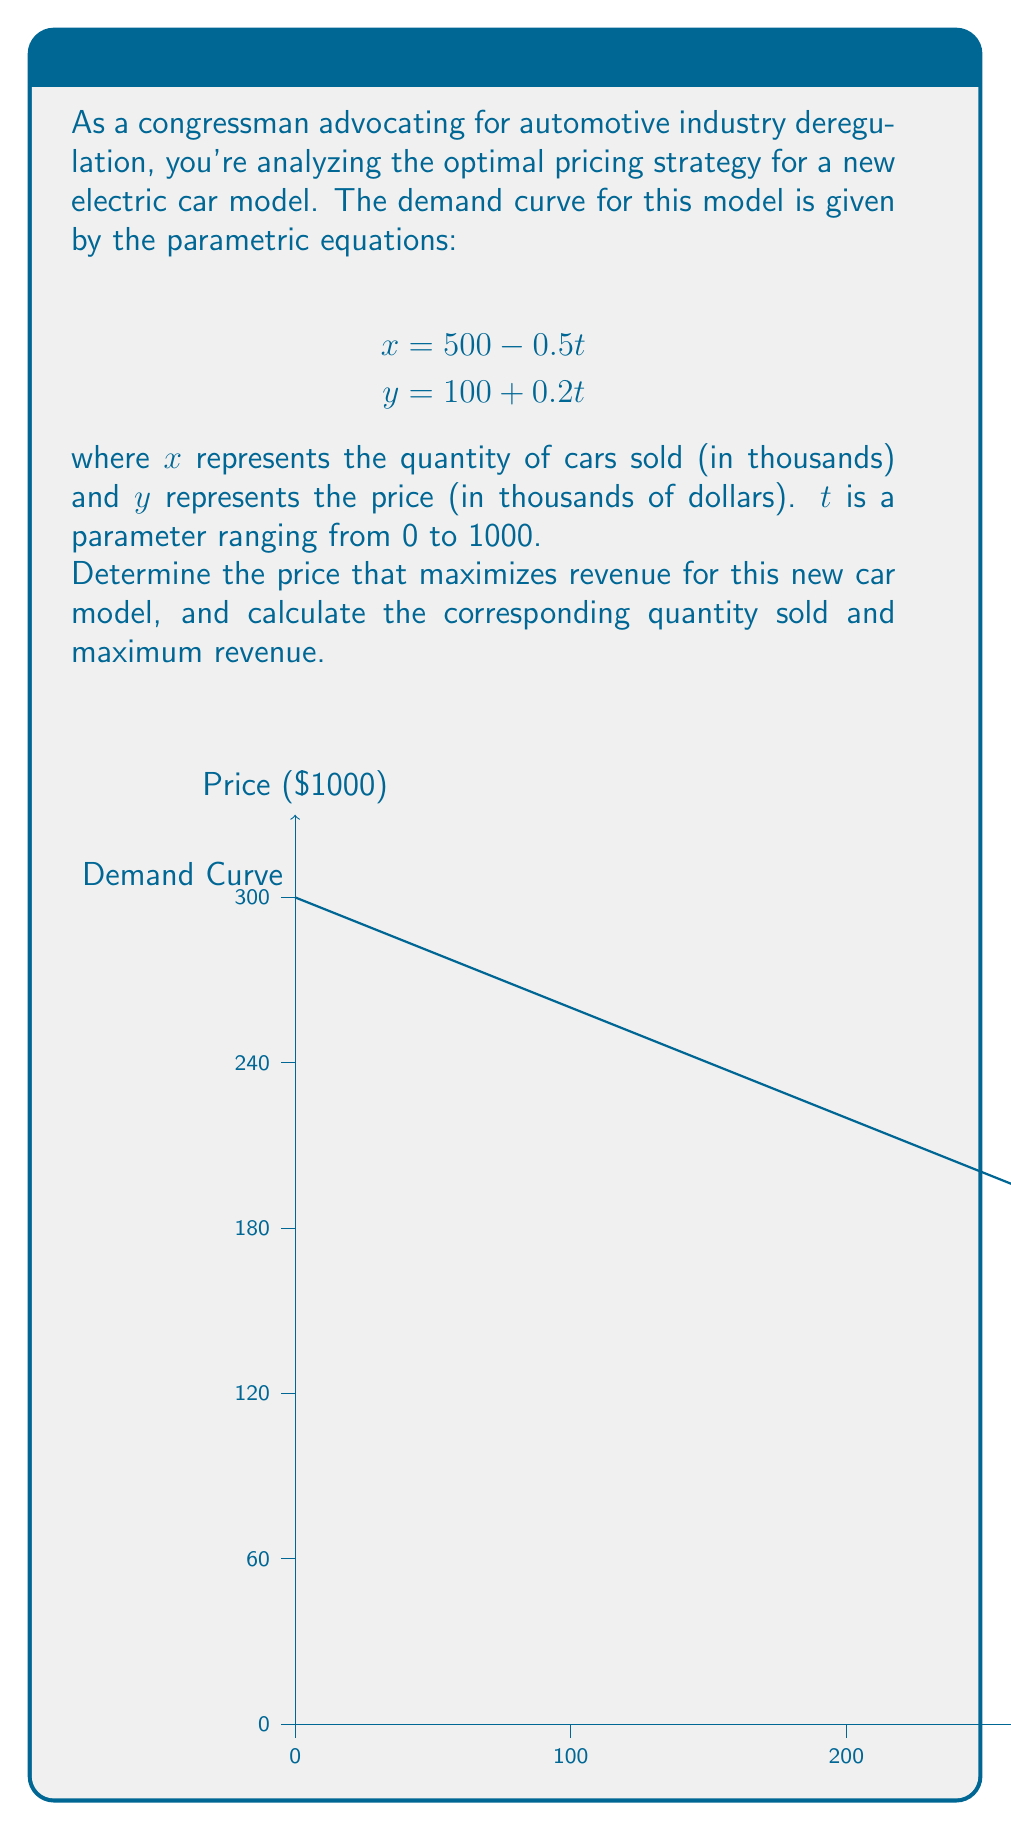Can you solve this math problem? Let's approach this step-by-step:

1) Revenue $R$ is equal to price times quantity. In parametric form:
   $$R = xy = (500 - 0.5t)(100 + 0.2t)$$

2) Expand this equation:
   $$R = 50000 - 50t + 100t - 0.1t^2 = 50000 + 50t - 0.1t^2$$

3) To find the maximum revenue, we need to find where $\frac{dR}{dt} = 0$:
   $$\frac{dR}{dt} = 50 - 0.2t$$

4) Set this equal to zero and solve for $t$:
   $$50 - 0.2t = 0$$
   $$-0.2t = -50$$
   $$t = 250$$

5) Now that we know the value of $t$ that maximizes revenue, we can find the corresponding $x$ and $y$:
   $$x = 500 - 0.5(250) = 375$$
   $$y = 100 + 0.2(250) = 150$$

6) The maximum revenue is:
   $$R = xy = 375 * 150 = 56,250$$

Therefore, the optimal price is $150,000, the quantity sold at this price is 375,000 units, and the maximum revenue is $56.25 billion.
Answer: Price: $150,000; Quantity: 375,000 units; Maximum Revenue: $56.25 billion 